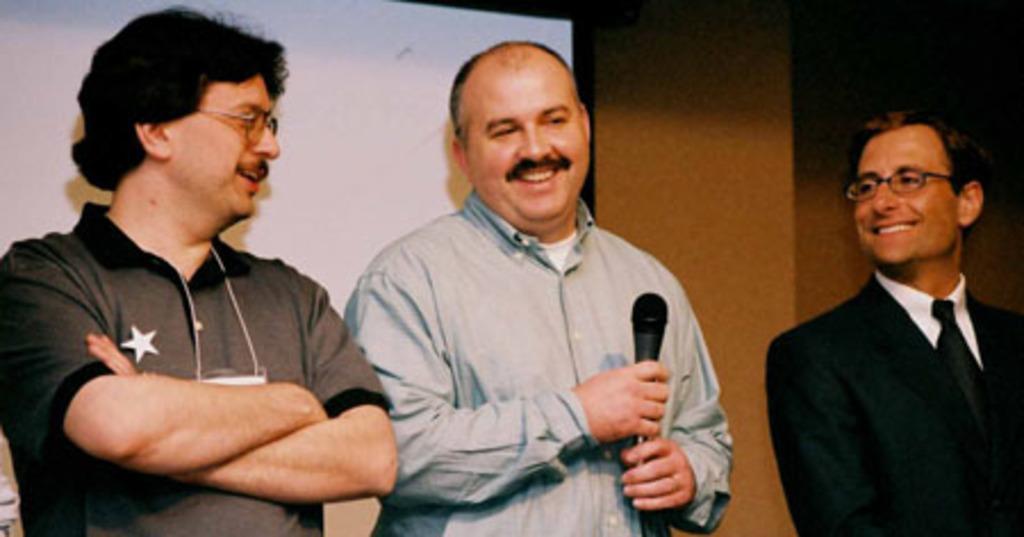Could you give a brief overview of what you see in this image? On the background we can see a wall and a board. Here we can see a man standing in the middle, holding a mike in his hand and smiling. Beside to him we can see two other men wearing spectacles , staring at him and smiling. 